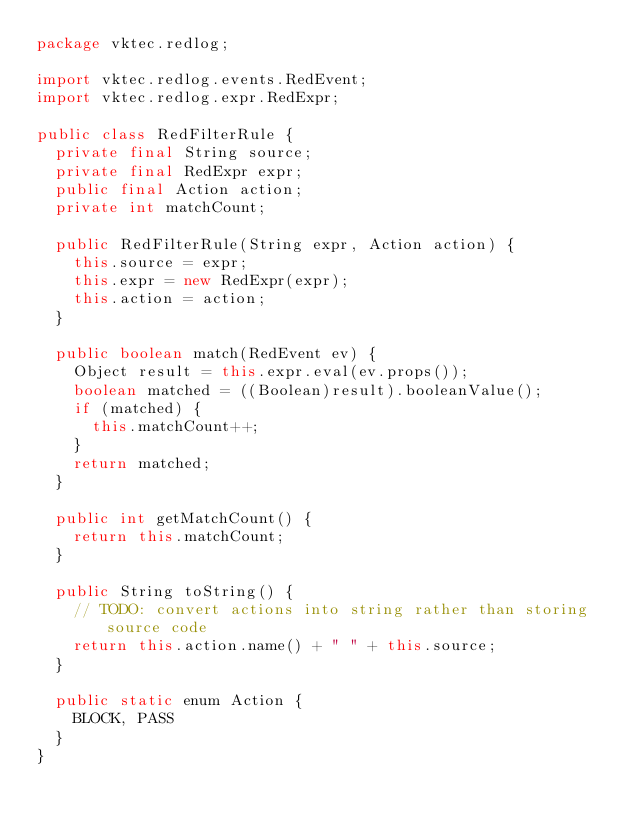Convert code to text. <code><loc_0><loc_0><loc_500><loc_500><_Java_>package vktec.redlog;

import vktec.redlog.events.RedEvent;
import vktec.redlog.expr.RedExpr;

public class RedFilterRule {
	private final String source;
	private final RedExpr expr;
	public final Action action;
	private int matchCount;

	public RedFilterRule(String expr, Action action) {
		this.source = expr;
		this.expr = new RedExpr(expr);
		this.action = action;
	}

	public boolean match(RedEvent ev) {
		Object result = this.expr.eval(ev.props());
		boolean matched = ((Boolean)result).booleanValue();
		if (matched) {
			this.matchCount++;
		}
		return matched;
	}

	public int getMatchCount() {
		return this.matchCount;
	}

	public String toString() {
		// TODO: convert actions into string rather than storing source code
		return this.action.name() + " " + this.source;
	}

	public static enum Action {
		BLOCK, PASS
	}
}
</code> 